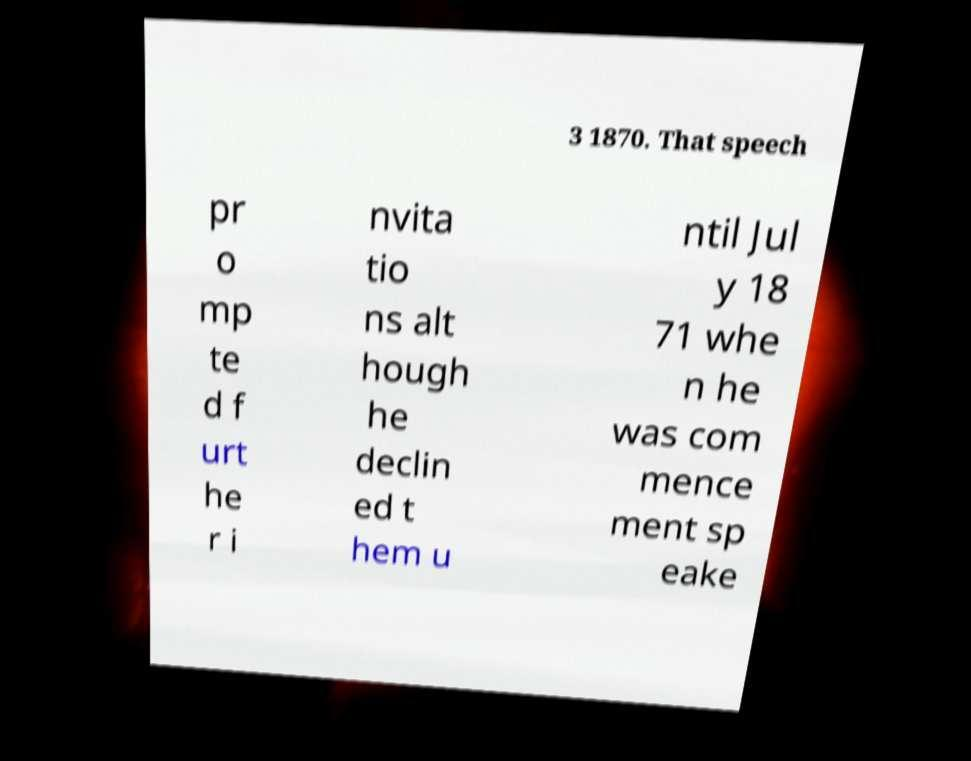Can you accurately transcribe the text from the provided image for me? 3 1870. That speech pr o mp te d f urt he r i nvita tio ns alt hough he declin ed t hem u ntil Jul y 18 71 whe n he was com mence ment sp eake 